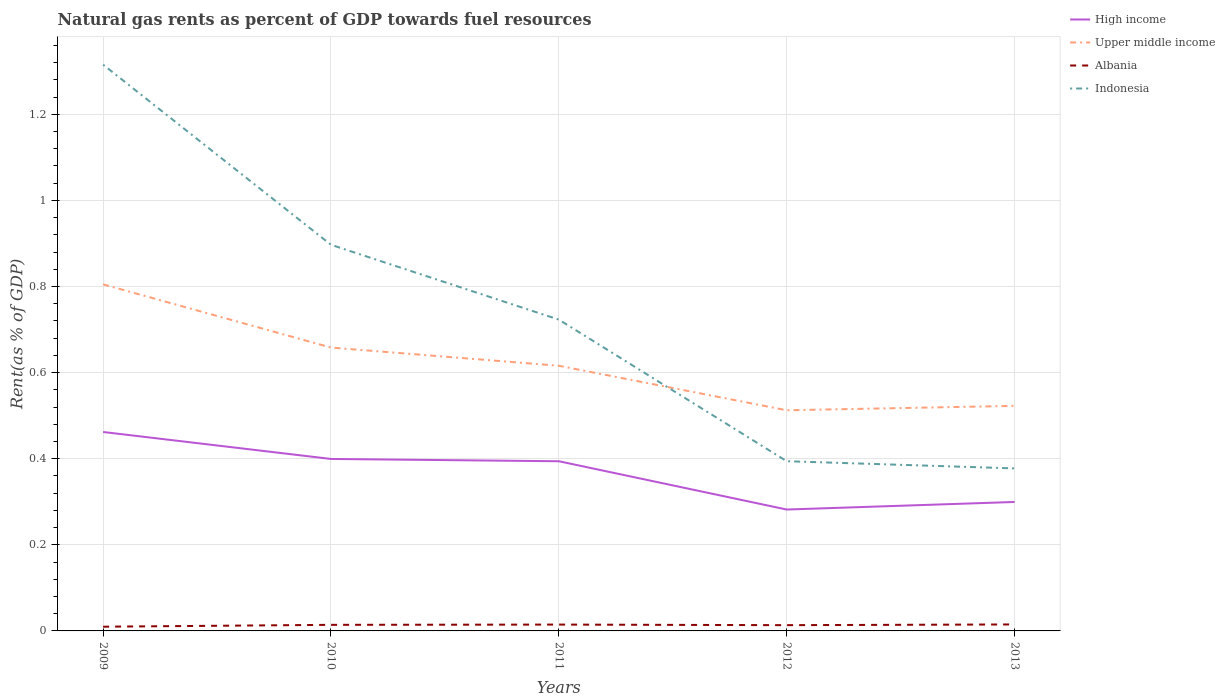How many different coloured lines are there?
Keep it short and to the point. 4. Across all years, what is the maximum matural gas rent in Indonesia?
Give a very brief answer. 0.38. What is the total matural gas rent in Albania in the graph?
Your answer should be compact. -0. What is the difference between the highest and the second highest matural gas rent in Indonesia?
Offer a terse response. 0.94. What is the difference between the highest and the lowest matural gas rent in High income?
Provide a short and direct response. 3. Is the matural gas rent in Upper middle income strictly greater than the matural gas rent in Albania over the years?
Provide a short and direct response. No. What is the difference between two consecutive major ticks on the Y-axis?
Your answer should be compact. 0.2. Does the graph contain any zero values?
Provide a succinct answer. No. How many legend labels are there?
Provide a succinct answer. 4. What is the title of the graph?
Make the answer very short. Natural gas rents as percent of GDP towards fuel resources. What is the label or title of the Y-axis?
Your answer should be compact. Rent(as % of GDP). What is the Rent(as % of GDP) of High income in 2009?
Your response must be concise. 0.46. What is the Rent(as % of GDP) in Upper middle income in 2009?
Make the answer very short. 0.8. What is the Rent(as % of GDP) of Albania in 2009?
Your response must be concise. 0.01. What is the Rent(as % of GDP) in Indonesia in 2009?
Ensure brevity in your answer.  1.32. What is the Rent(as % of GDP) in High income in 2010?
Ensure brevity in your answer.  0.4. What is the Rent(as % of GDP) of Upper middle income in 2010?
Your response must be concise. 0.66. What is the Rent(as % of GDP) of Albania in 2010?
Your answer should be compact. 0.01. What is the Rent(as % of GDP) of Indonesia in 2010?
Provide a short and direct response. 0.9. What is the Rent(as % of GDP) of High income in 2011?
Your answer should be compact. 0.39. What is the Rent(as % of GDP) of Upper middle income in 2011?
Give a very brief answer. 0.62. What is the Rent(as % of GDP) in Albania in 2011?
Your response must be concise. 0.01. What is the Rent(as % of GDP) in Indonesia in 2011?
Your answer should be very brief. 0.72. What is the Rent(as % of GDP) in High income in 2012?
Provide a short and direct response. 0.28. What is the Rent(as % of GDP) in Upper middle income in 2012?
Ensure brevity in your answer.  0.51. What is the Rent(as % of GDP) of Albania in 2012?
Provide a short and direct response. 0.01. What is the Rent(as % of GDP) of Indonesia in 2012?
Provide a succinct answer. 0.39. What is the Rent(as % of GDP) of High income in 2013?
Give a very brief answer. 0.3. What is the Rent(as % of GDP) of Upper middle income in 2013?
Offer a very short reply. 0.52. What is the Rent(as % of GDP) in Albania in 2013?
Provide a short and direct response. 0.02. What is the Rent(as % of GDP) in Indonesia in 2013?
Make the answer very short. 0.38. Across all years, what is the maximum Rent(as % of GDP) in High income?
Make the answer very short. 0.46. Across all years, what is the maximum Rent(as % of GDP) of Upper middle income?
Give a very brief answer. 0.8. Across all years, what is the maximum Rent(as % of GDP) in Albania?
Your answer should be compact. 0.02. Across all years, what is the maximum Rent(as % of GDP) in Indonesia?
Make the answer very short. 1.32. Across all years, what is the minimum Rent(as % of GDP) in High income?
Your answer should be compact. 0.28. Across all years, what is the minimum Rent(as % of GDP) in Upper middle income?
Your answer should be compact. 0.51. Across all years, what is the minimum Rent(as % of GDP) of Albania?
Make the answer very short. 0.01. Across all years, what is the minimum Rent(as % of GDP) in Indonesia?
Ensure brevity in your answer.  0.38. What is the total Rent(as % of GDP) in High income in the graph?
Offer a very short reply. 1.84. What is the total Rent(as % of GDP) in Upper middle income in the graph?
Offer a very short reply. 3.11. What is the total Rent(as % of GDP) of Albania in the graph?
Offer a terse response. 0.07. What is the total Rent(as % of GDP) of Indonesia in the graph?
Ensure brevity in your answer.  3.71. What is the difference between the Rent(as % of GDP) in High income in 2009 and that in 2010?
Provide a succinct answer. 0.06. What is the difference between the Rent(as % of GDP) of Upper middle income in 2009 and that in 2010?
Offer a very short reply. 0.15. What is the difference between the Rent(as % of GDP) in Albania in 2009 and that in 2010?
Offer a very short reply. -0. What is the difference between the Rent(as % of GDP) of Indonesia in 2009 and that in 2010?
Offer a terse response. 0.42. What is the difference between the Rent(as % of GDP) of High income in 2009 and that in 2011?
Provide a short and direct response. 0.07. What is the difference between the Rent(as % of GDP) of Upper middle income in 2009 and that in 2011?
Ensure brevity in your answer.  0.19. What is the difference between the Rent(as % of GDP) of Albania in 2009 and that in 2011?
Offer a terse response. -0. What is the difference between the Rent(as % of GDP) of Indonesia in 2009 and that in 2011?
Provide a short and direct response. 0.59. What is the difference between the Rent(as % of GDP) of High income in 2009 and that in 2012?
Your answer should be very brief. 0.18. What is the difference between the Rent(as % of GDP) of Upper middle income in 2009 and that in 2012?
Ensure brevity in your answer.  0.29. What is the difference between the Rent(as % of GDP) in Albania in 2009 and that in 2012?
Your answer should be very brief. -0. What is the difference between the Rent(as % of GDP) in Indonesia in 2009 and that in 2012?
Make the answer very short. 0.92. What is the difference between the Rent(as % of GDP) in High income in 2009 and that in 2013?
Your answer should be compact. 0.16. What is the difference between the Rent(as % of GDP) in Upper middle income in 2009 and that in 2013?
Your answer should be compact. 0.28. What is the difference between the Rent(as % of GDP) in Albania in 2009 and that in 2013?
Your answer should be compact. -0.01. What is the difference between the Rent(as % of GDP) in Indonesia in 2009 and that in 2013?
Provide a short and direct response. 0.94. What is the difference between the Rent(as % of GDP) in High income in 2010 and that in 2011?
Keep it short and to the point. 0.01. What is the difference between the Rent(as % of GDP) of Upper middle income in 2010 and that in 2011?
Offer a terse response. 0.04. What is the difference between the Rent(as % of GDP) of Albania in 2010 and that in 2011?
Ensure brevity in your answer.  -0. What is the difference between the Rent(as % of GDP) in Indonesia in 2010 and that in 2011?
Your response must be concise. 0.17. What is the difference between the Rent(as % of GDP) of High income in 2010 and that in 2012?
Ensure brevity in your answer.  0.12. What is the difference between the Rent(as % of GDP) in Upper middle income in 2010 and that in 2012?
Give a very brief answer. 0.15. What is the difference between the Rent(as % of GDP) of Albania in 2010 and that in 2012?
Make the answer very short. 0. What is the difference between the Rent(as % of GDP) of Indonesia in 2010 and that in 2012?
Offer a terse response. 0.5. What is the difference between the Rent(as % of GDP) in High income in 2010 and that in 2013?
Ensure brevity in your answer.  0.1. What is the difference between the Rent(as % of GDP) of Upper middle income in 2010 and that in 2013?
Ensure brevity in your answer.  0.14. What is the difference between the Rent(as % of GDP) of Albania in 2010 and that in 2013?
Provide a short and direct response. -0. What is the difference between the Rent(as % of GDP) of Indonesia in 2010 and that in 2013?
Provide a succinct answer. 0.52. What is the difference between the Rent(as % of GDP) of High income in 2011 and that in 2012?
Keep it short and to the point. 0.11. What is the difference between the Rent(as % of GDP) in Upper middle income in 2011 and that in 2012?
Your response must be concise. 0.1. What is the difference between the Rent(as % of GDP) in Albania in 2011 and that in 2012?
Keep it short and to the point. 0. What is the difference between the Rent(as % of GDP) in Indonesia in 2011 and that in 2012?
Offer a very short reply. 0.33. What is the difference between the Rent(as % of GDP) in High income in 2011 and that in 2013?
Your response must be concise. 0.09. What is the difference between the Rent(as % of GDP) in Upper middle income in 2011 and that in 2013?
Provide a succinct answer. 0.09. What is the difference between the Rent(as % of GDP) in Albania in 2011 and that in 2013?
Provide a short and direct response. -0. What is the difference between the Rent(as % of GDP) of Indonesia in 2011 and that in 2013?
Offer a very short reply. 0.35. What is the difference between the Rent(as % of GDP) of High income in 2012 and that in 2013?
Offer a very short reply. -0.02. What is the difference between the Rent(as % of GDP) in Upper middle income in 2012 and that in 2013?
Ensure brevity in your answer.  -0.01. What is the difference between the Rent(as % of GDP) in Albania in 2012 and that in 2013?
Your response must be concise. -0. What is the difference between the Rent(as % of GDP) of Indonesia in 2012 and that in 2013?
Make the answer very short. 0.02. What is the difference between the Rent(as % of GDP) of High income in 2009 and the Rent(as % of GDP) of Upper middle income in 2010?
Your response must be concise. -0.2. What is the difference between the Rent(as % of GDP) in High income in 2009 and the Rent(as % of GDP) in Albania in 2010?
Make the answer very short. 0.45. What is the difference between the Rent(as % of GDP) of High income in 2009 and the Rent(as % of GDP) of Indonesia in 2010?
Provide a short and direct response. -0.43. What is the difference between the Rent(as % of GDP) in Upper middle income in 2009 and the Rent(as % of GDP) in Albania in 2010?
Offer a very short reply. 0.79. What is the difference between the Rent(as % of GDP) in Upper middle income in 2009 and the Rent(as % of GDP) in Indonesia in 2010?
Give a very brief answer. -0.09. What is the difference between the Rent(as % of GDP) of Albania in 2009 and the Rent(as % of GDP) of Indonesia in 2010?
Offer a terse response. -0.89. What is the difference between the Rent(as % of GDP) of High income in 2009 and the Rent(as % of GDP) of Upper middle income in 2011?
Provide a short and direct response. -0.15. What is the difference between the Rent(as % of GDP) in High income in 2009 and the Rent(as % of GDP) in Albania in 2011?
Your answer should be very brief. 0.45. What is the difference between the Rent(as % of GDP) of High income in 2009 and the Rent(as % of GDP) of Indonesia in 2011?
Ensure brevity in your answer.  -0.26. What is the difference between the Rent(as % of GDP) in Upper middle income in 2009 and the Rent(as % of GDP) in Albania in 2011?
Provide a succinct answer. 0.79. What is the difference between the Rent(as % of GDP) in Upper middle income in 2009 and the Rent(as % of GDP) in Indonesia in 2011?
Make the answer very short. 0.08. What is the difference between the Rent(as % of GDP) in Albania in 2009 and the Rent(as % of GDP) in Indonesia in 2011?
Give a very brief answer. -0.71. What is the difference between the Rent(as % of GDP) of High income in 2009 and the Rent(as % of GDP) of Upper middle income in 2012?
Make the answer very short. -0.05. What is the difference between the Rent(as % of GDP) in High income in 2009 and the Rent(as % of GDP) in Albania in 2012?
Make the answer very short. 0.45. What is the difference between the Rent(as % of GDP) in High income in 2009 and the Rent(as % of GDP) in Indonesia in 2012?
Your answer should be very brief. 0.07. What is the difference between the Rent(as % of GDP) of Upper middle income in 2009 and the Rent(as % of GDP) of Albania in 2012?
Offer a very short reply. 0.79. What is the difference between the Rent(as % of GDP) of Upper middle income in 2009 and the Rent(as % of GDP) of Indonesia in 2012?
Your response must be concise. 0.41. What is the difference between the Rent(as % of GDP) of Albania in 2009 and the Rent(as % of GDP) of Indonesia in 2012?
Keep it short and to the point. -0.38. What is the difference between the Rent(as % of GDP) of High income in 2009 and the Rent(as % of GDP) of Upper middle income in 2013?
Make the answer very short. -0.06. What is the difference between the Rent(as % of GDP) of High income in 2009 and the Rent(as % of GDP) of Albania in 2013?
Provide a short and direct response. 0.45. What is the difference between the Rent(as % of GDP) of High income in 2009 and the Rent(as % of GDP) of Indonesia in 2013?
Your answer should be very brief. 0.08. What is the difference between the Rent(as % of GDP) of Upper middle income in 2009 and the Rent(as % of GDP) of Albania in 2013?
Provide a short and direct response. 0.79. What is the difference between the Rent(as % of GDP) in Upper middle income in 2009 and the Rent(as % of GDP) in Indonesia in 2013?
Provide a succinct answer. 0.43. What is the difference between the Rent(as % of GDP) of Albania in 2009 and the Rent(as % of GDP) of Indonesia in 2013?
Ensure brevity in your answer.  -0.37. What is the difference between the Rent(as % of GDP) in High income in 2010 and the Rent(as % of GDP) in Upper middle income in 2011?
Provide a succinct answer. -0.22. What is the difference between the Rent(as % of GDP) in High income in 2010 and the Rent(as % of GDP) in Albania in 2011?
Provide a short and direct response. 0.38. What is the difference between the Rent(as % of GDP) of High income in 2010 and the Rent(as % of GDP) of Indonesia in 2011?
Offer a very short reply. -0.32. What is the difference between the Rent(as % of GDP) in Upper middle income in 2010 and the Rent(as % of GDP) in Albania in 2011?
Your answer should be very brief. 0.64. What is the difference between the Rent(as % of GDP) of Upper middle income in 2010 and the Rent(as % of GDP) of Indonesia in 2011?
Your response must be concise. -0.06. What is the difference between the Rent(as % of GDP) of Albania in 2010 and the Rent(as % of GDP) of Indonesia in 2011?
Keep it short and to the point. -0.71. What is the difference between the Rent(as % of GDP) in High income in 2010 and the Rent(as % of GDP) in Upper middle income in 2012?
Ensure brevity in your answer.  -0.11. What is the difference between the Rent(as % of GDP) of High income in 2010 and the Rent(as % of GDP) of Albania in 2012?
Your answer should be very brief. 0.39. What is the difference between the Rent(as % of GDP) of High income in 2010 and the Rent(as % of GDP) of Indonesia in 2012?
Make the answer very short. 0.01. What is the difference between the Rent(as % of GDP) of Upper middle income in 2010 and the Rent(as % of GDP) of Albania in 2012?
Keep it short and to the point. 0.64. What is the difference between the Rent(as % of GDP) in Upper middle income in 2010 and the Rent(as % of GDP) in Indonesia in 2012?
Offer a very short reply. 0.26. What is the difference between the Rent(as % of GDP) in Albania in 2010 and the Rent(as % of GDP) in Indonesia in 2012?
Give a very brief answer. -0.38. What is the difference between the Rent(as % of GDP) of High income in 2010 and the Rent(as % of GDP) of Upper middle income in 2013?
Provide a succinct answer. -0.12. What is the difference between the Rent(as % of GDP) in High income in 2010 and the Rent(as % of GDP) in Albania in 2013?
Your answer should be compact. 0.38. What is the difference between the Rent(as % of GDP) of High income in 2010 and the Rent(as % of GDP) of Indonesia in 2013?
Your answer should be very brief. 0.02. What is the difference between the Rent(as % of GDP) in Upper middle income in 2010 and the Rent(as % of GDP) in Albania in 2013?
Provide a short and direct response. 0.64. What is the difference between the Rent(as % of GDP) in Upper middle income in 2010 and the Rent(as % of GDP) in Indonesia in 2013?
Offer a terse response. 0.28. What is the difference between the Rent(as % of GDP) in Albania in 2010 and the Rent(as % of GDP) in Indonesia in 2013?
Provide a short and direct response. -0.36. What is the difference between the Rent(as % of GDP) in High income in 2011 and the Rent(as % of GDP) in Upper middle income in 2012?
Your response must be concise. -0.12. What is the difference between the Rent(as % of GDP) in High income in 2011 and the Rent(as % of GDP) in Albania in 2012?
Offer a terse response. 0.38. What is the difference between the Rent(as % of GDP) of High income in 2011 and the Rent(as % of GDP) of Indonesia in 2012?
Your answer should be very brief. -0. What is the difference between the Rent(as % of GDP) of Upper middle income in 2011 and the Rent(as % of GDP) of Albania in 2012?
Your answer should be very brief. 0.6. What is the difference between the Rent(as % of GDP) of Upper middle income in 2011 and the Rent(as % of GDP) of Indonesia in 2012?
Provide a short and direct response. 0.22. What is the difference between the Rent(as % of GDP) of Albania in 2011 and the Rent(as % of GDP) of Indonesia in 2012?
Provide a short and direct response. -0.38. What is the difference between the Rent(as % of GDP) of High income in 2011 and the Rent(as % of GDP) of Upper middle income in 2013?
Give a very brief answer. -0.13. What is the difference between the Rent(as % of GDP) in High income in 2011 and the Rent(as % of GDP) in Albania in 2013?
Ensure brevity in your answer.  0.38. What is the difference between the Rent(as % of GDP) in High income in 2011 and the Rent(as % of GDP) in Indonesia in 2013?
Give a very brief answer. 0.02. What is the difference between the Rent(as % of GDP) in Upper middle income in 2011 and the Rent(as % of GDP) in Albania in 2013?
Provide a short and direct response. 0.6. What is the difference between the Rent(as % of GDP) of Upper middle income in 2011 and the Rent(as % of GDP) of Indonesia in 2013?
Provide a succinct answer. 0.24. What is the difference between the Rent(as % of GDP) in Albania in 2011 and the Rent(as % of GDP) in Indonesia in 2013?
Offer a very short reply. -0.36. What is the difference between the Rent(as % of GDP) in High income in 2012 and the Rent(as % of GDP) in Upper middle income in 2013?
Offer a very short reply. -0.24. What is the difference between the Rent(as % of GDP) in High income in 2012 and the Rent(as % of GDP) in Albania in 2013?
Offer a terse response. 0.27. What is the difference between the Rent(as % of GDP) of High income in 2012 and the Rent(as % of GDP) of Indonesia in 2013?
Your answer should be compact. -0.1. What is the difference between the Rent(as % of GDP) of Upper middle income in 2012 and the Rent(as % of GDP) of Albania in 2013?
Make the answer very short. 0.5. What is the difference between the Rent(as % of GDP) of Upper middle income in 2012 and the Rent(as % of GDP) of Indonesia in 2013?
Give a very brief answer. 0.14. What is the difference between the Rent(as % of GDP) of Albania in 2012 and the Rent(as % of GDP) of Indonesia in 2013?
Provide a succinct answer. -0.36. What is the average Rent(as % of GDP) in High income per year?
Offer a terse response. 0.37. What is the average Rent(as % of GDP) of Upper middle income per year?
Give a very brief answer. 0.62. What is the average Rent(as % of GDP) of Albania per year?
Keep it short and to the point. 0.01. What is the average Rent(as % of GDP) in Indonesia per year?
Your response must be concise. 0.74. In the year 2009, what is the difference between the Rent(as % of GDP) of High income and Rent(as % of GDP) of Upper middle income?
Your answer should be very brief. -0.34. In the year 2009, what is the difference between the Rent(as % of GDP) in High income and Rent(as % of GDP) in Albania?
Make the answer very short. 0.45. In the year 2009, what is the difference between the Rent(as % of GDP) in High income and Rent(as % of GDP) in Indonesia?
Make the answer very short. -0.85. In the year 2009, what is the difference between the Rent(as % of GDP) of Upper middle income and Rent(as % of GDP) of Albania?
Give a very brief answer. 0.8. In the year 2009, what is the difference between the Rent(as % of GDP) in Upper middle income and Rent(as % of GDP) in Indonesia?
Your response must be concise. -0.51. In the year 2009, what is the difference between the Rent(as % of GDP) of Albania and Rent(as % of GDP) of Indonesia?
Offer a very short reply. -1.31. In the year 2010, what is the difference between the Rent(as % of GDP) of High income and Rent(as % of GDP) of Upper middle income?
Your answer should be very brief. -0.26. In the year 2010, what is the difference between the Rent(as % of GDP) of High income and Rent(as % of GDP) of Albania?
Your response must be concise. 0.39. In the year 2010, what is the difference between the Rent(as % of GDP) in High income and Rent(as % of GDP) in Indonesia?
Provide a succinct answer. -0.5. In the year 2010, what is the difference between the Rent(as % of GDP) in Upper middle income and Rent(as % of GDP) in Albania?
Keep it short and to the point. 0.64. In the year 2010, what is the difference between the Rent(as % of GDP) in Upper middle income and Rent(as % of GDP) in Indonesia?
Your response must be concise. -0.24. In the year 2010, what is the difference between the Rent(as % of GDP) in Albania and Rent(as % of GDP) in Indonesia?
Your response must be concise. -0.88. In the year 2011, what is the difference between the Rent(as % of GDP) of High income and Rent(as % of GDP) of Upper middle income?
Ensure brevity in your answer.  -0.22. In the year 2011, what is the difference between the Rent(as % of GDP) of High income and Rent(as % of GDP) of Albania?
Your response must be concise. 0.38. In the year 2011, what is the difference between the Rent(as % of GDP) of High income and Rent(as % of GDP) of Indonesia?
Provide a succinct answer. -0.33. In the year 2011, what is the difference between the Rent(as % of GDP) in Upper middle income and Rent(as % of GDP) in Albania?
Ensure brevity in your answer.  0.6. In the year 2011, what is the difference between the Rent(as % of GDP) of Upper middle income and Rent(as % of GDP) of Indonesia?
Your response must be concise. -0.11. In the year 2011, what is the difference between the Rent(as % of GDP) in Albania and Rent(as % of GDP) in Indonesia?
Your answer should be compact. -0.71. In the year 2012, what is the difference between the Rent(as % of GDP) of High income and Rent(as % of GDP) of Upper middle income?
Make the answer very short. -0.23. In the year 2012, what is the difference between the Rent(as % of GDP) of High income and Rent(as % of GDP) of Albania?
Offer a very short reply. 0.27. In the year 2012, what is the difference between the Rent(as % of GDP) in High income and Rent(as % of GDP) in Indonesia?
Your response must be concise. -0.11. In the year 2012, what is the difference between the Rent(as % of GDP) in Upper middle income and Rent(as % of GDP) in Albania?
Your response must be concise. 0.5. In the year 2012, what is the difference between the Rent(as % of GDP) in Upper middle income and Rent(as % of GDP) in Indonesia?
Offer a very short reply. 0.12. In the year 2012, what is the difference between the Rent(as % of GDP) of Albania and Rent(as % of GDP) of Indonesia?
Give a very brief answer. -0.38. In the year 2013, what is the difference between the Rent(as % of GDP) in High income and Rent(as % of GDP) in Upper middle income?
Your answer should be very brief. -0.22. In the year 2013, what is the difference between the Rent(as % of GDP) of High income and Rent(as % of GDP) of Albania?
Offer a very short reply. 0.28. In the year 2013, what is the difference between the Rent(as % of GDP) in High income and Rent(as % of GDP) in Indonesia?
Your answer should be very brief. -0.08. In the year 2013, what is the difference between the Rent(as % of GDP) of Upper middle income and Rent(as % of GDP) of Albania?
Your answer should be compact. 0.51. In the year 2013, what is the difference between the Rent(as % of GDP) of Upper middle income and Rent(as % of GDP) of Indonesia?
Offer a very short reply. 0.15. In the year 2013, what is the difference between the Rent(as % of GDP) of Albania and Rent(as % of GDP) of Indonesia?
Give a very brief answer. -0.36. What is the ratio of the Rent(as % of GDP) of High income in 2009 to that in 2010?
Keep it short and to the point. 1.16. What is the ratio of the Rent(as % of GDP) of Upper middle income in 2009 to that in 2010?
Provide a short and direct response. 1.22. What is the ratio of the Rent(as % of GDP) in Albania in 2009 to that in 2010?
Offer a terse response. 0.69. What is the ratio of the Rent(as % of GDP) in Indonesia in 2009 to that in 2010?
Your answer should be very brief. 1.47. What is the ratio of the Rent(as % of GDP) of High income in 2009 to that in 2011?
Provide a short and direct response. 1.17. What is the ratio of the Rent(as % of GDP) in Upper middle income in 2009 to that in 2011?
Your answer should be very brief. 1.31. What is the ratio of the Rent(as % of GDP) of Albania in 2009 to that in 2011?
Keep it short and to the point. 0.67. What is the ratio of the Rent(as % of GDP) in Indonesia in 2009 to that in 2011?
Offer a very short reply. 1.82. What is the ratio of the Rent(as % of GDP) of High income in 2009 to that in 2012?
Provide a succinct answer. 1.64. What is the ratio of the Rent(as % of GDP) in Upper middle income in 2009 to that in 2012?
Your answer should be very brief. 1.57. What is the ratio of the Rent(as % of GDP) of Albania in 2009 to that in 2012?
Your response must be concise. 0.73. What is the ratio of the Rent(as % of GDP) in Indonesia in 2009 to that in 2012?
Offer a very short reply. 3.34. What is the ratio of the Rent(as % of GDP) of High income in 2009 to that in 2013?
Offer a very short reply. 1.54. What is the ratio of the Rent(as % of GDP) of Upper middle income in 2009 to that in 2013?
Your answer should be compact. 1.54. What is the ratio of the Rent(as % of GDP) of Albania in 2009 to that in 2013?
Ensure brevity in your answer.  0.65. What is the ratio of the Rent(as % of GDP) of Indonesia in 2009 to that in 2013?
Provide a succinct answer. 3.48. What is the ratio of the Rent(as % of GDP) in High income in 2010 to that in 2011?
Ensure brevity in your answer.  1.01. What is the ratio of the Rent(as % of GDP) in Upper middle income in 2010 to that in 2011?
Give a very brief answer. 1.07. What is the ratio of the Rent(as % of GDP) of Albania in 2010 to that in 2011?
Keep it short and to the point. 0.96. What is the ratio of the Rent(as % of GDP) in Indonesia in 2010 to that in 2011?
Your answer should be very brief. 1.24. What is the ratio of the Rent(as % of GDP) of High income in 2010 to that in 2012?
Make the answer very short. 1.42. What is the ratio of the Rent(as % of GDP) in Upper middle income in 2010 to that in 2012?
Offer a very short reply. 1.28. What is the ratio of the Rent(as % of GDP) in Albania in 2010 to that in 2012?
Your answer should be very brief. 1.06. What is the ratio of the Rent(as % of GDP) in Indonesia in 2010 to that in 2012?
Provide a short and direct response. 2.28. What is the ratio of the Rent(as % of GDP) of High income in 2010 to that in 2013?
Offer a very short reply. 1.33. What is the ratio of the Rent(as % of GDP) in Upper middle income in 2010 to that in 2013?
Give a very brief answer. 1.26. What is the ratio of the Rent(as % of GDP) in Albania in 2010 to that in 2013?
Make the answer very short. 0.94. What is the ratio of the Rent(as % of GDP) in Indonesia in 2010 to that in 2013?
Keep it short and to the point. 2.38. What is the ratio of the Rent(as % of GDP) in High income in 2011 to that in 2012?
Offer a terse response. 1.4. What is the ratio of the Rent(as % of GDP) in Upper middle income in 2011 to that in 2012?
Your answer should be very brief. 1.2. What is the ratio of the Rent(as % of GDP) of Albania in 2011 to that in 2012?
Provide a succinct answer. 1.1. What is the ratio of the Rent(as % of GDP) in Indonesia in 2011 to that in 2012?
Your answer should be very brief. 1.83. What is the ratio of the Rent(as % of GDP) in High income in 2011 to that in 2013?
Your response must be concise. 1.32. What is the ratio of the Rent(as % of GDP) of Upper middle income in 2011 to that in 2013?
Offer a terse response. 1.18. What is the ratio of the Rent(as % of GDP) of Albania in 2011 to that in 2013?
Make the answer very short. 0.98. What is the ratio of the Rent(as % of GDP) in Indonesia in 2011 to that in 2013?
Make the answer very short. 1.92. What is the ratio of the Rent(as % of GDP) in High income in 2012 to that in 2013?
Your answer should be compact. 0.94. What is the ratio of the Rent(as % of GDP) in Upper middle income in 2012 to that in 2013?
Provide a short and direct response. 0.98. What is the ratio of the Rent(as % of GDP) of Albania in 2012 to that in 2013?
Provide a succinct answer. 0.89. What is the ratio of the Rent(as % of GDP) in Indonesia in 2012 to that in 2013?
Ensure brevity in your answer.  1.04. What is the difference between the highest and the second highest Rent(as % of GDP) in High income?
Your answer should be compact. 0.06. What is the difference between the highest and the second highest Rent(as % of GDP) of Upper middle income?
Your answer should be very brief. 0.15. What is the difference between the highest and the second highest Rent(as % of GDP) of Albania?
Provide a short and direct response. 0. What is the difference between the highest and the second highest Rent(as % of GDP) in Indonesia?
Your answer should be very brief. 0.42. What is the difference between the highest and the lowest Rent(as % of GDP) in High income?
Make the answer very short. 0.18. What is the difference between the highest and the lowest Rent(as % of GDP) in Upper middle income?
Your answer should be very brief. 0.29. What is the difference between the highest and the lowest Rent(as % of GDP) in Albania?
Your response must be concise. 0.01. What is the difference between the highest and the lowest Rent(as % of GDP) of Indonesia?
Your response must be concise. 0.94. 